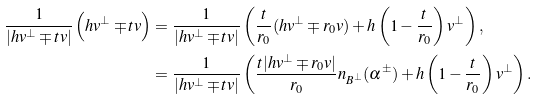<formula> <loc_0><loc_0><loc_500><loc_500>\frac { 1 } { | h v ^ { \perp } \mp t v | } \left ( h v ^ { \perp } \mp t v \right ) & = \frac { 1 } { | h v ^ { \perp } \mp t v | } \left ( \frac { t } { r _ { 0 } } ( h v ^ { \perp } \mp r _ { 0 } v ) + h \left ( 1 - \frac { t } { r _ { 0 } } \right ) v ^ { \perp } \right ) , \\ & = \frac { 1 } { | h v ^ { \perp } \mp t v | } \left ( \frac { t | h v ^ { \perp } \mp r _ { 0 } v | } { r _ { 0 } } n _ { B ^ { \perp } } ( \alpha ^ { \pm } ) + h \left ( 1 - \frac { t } { r _ { 0 } } \right ) v ^ { \perp } \right ) .</formula> 